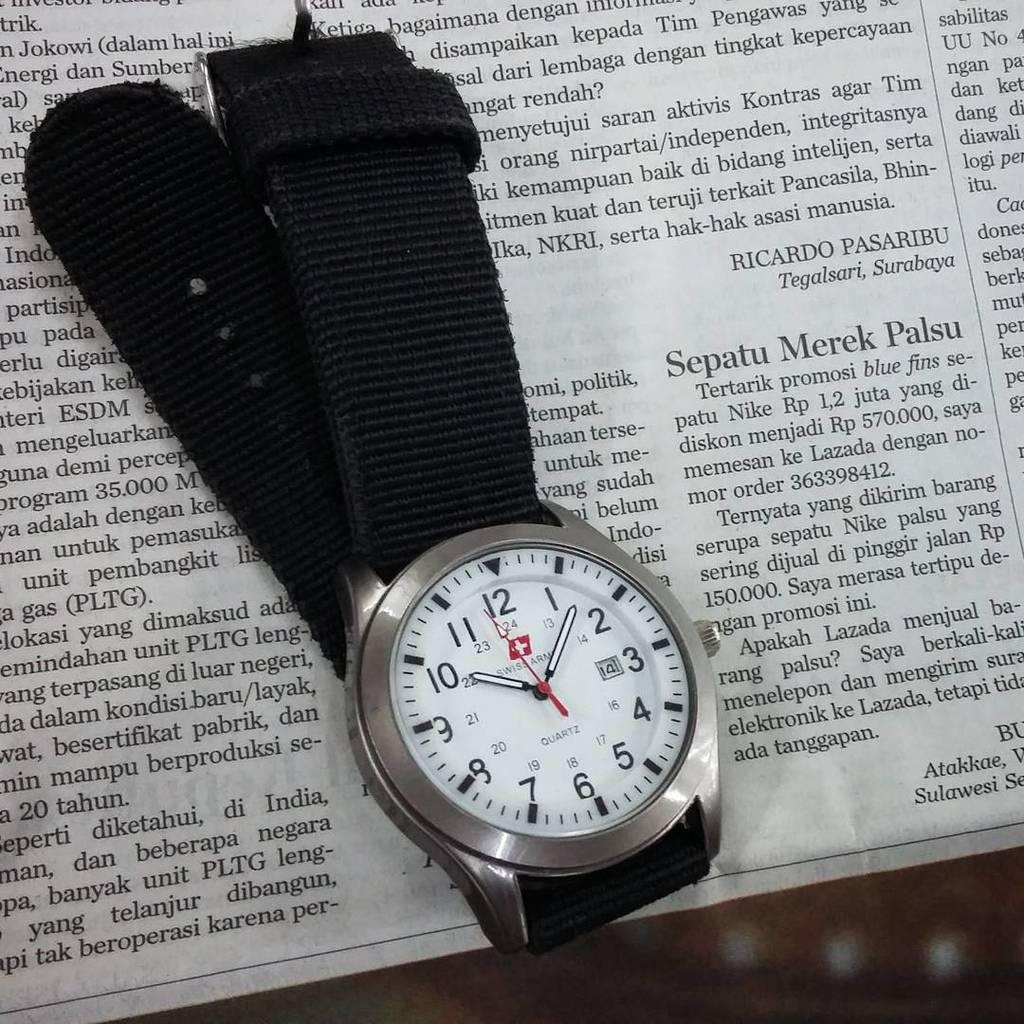<image>
Create a compact narrative representing the image presented. A Swiss Army watch on a newspaper has the time of 10:06. 